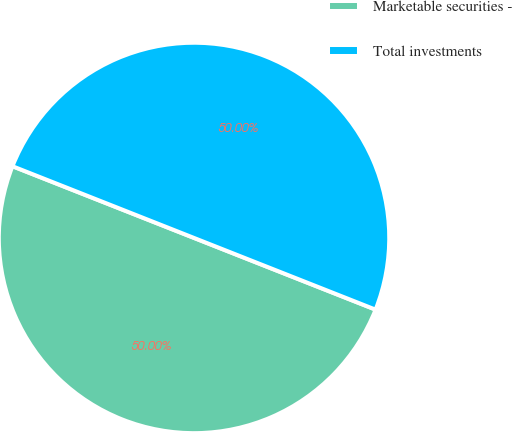Convert chart. <chart><loc_0><loc_0><loc_500><loc_500><pie_chart><fcel>Marketable securities -<fcel>Total investments<nl><fcel>50.0%<fcel>50.0%<nl></chart> 